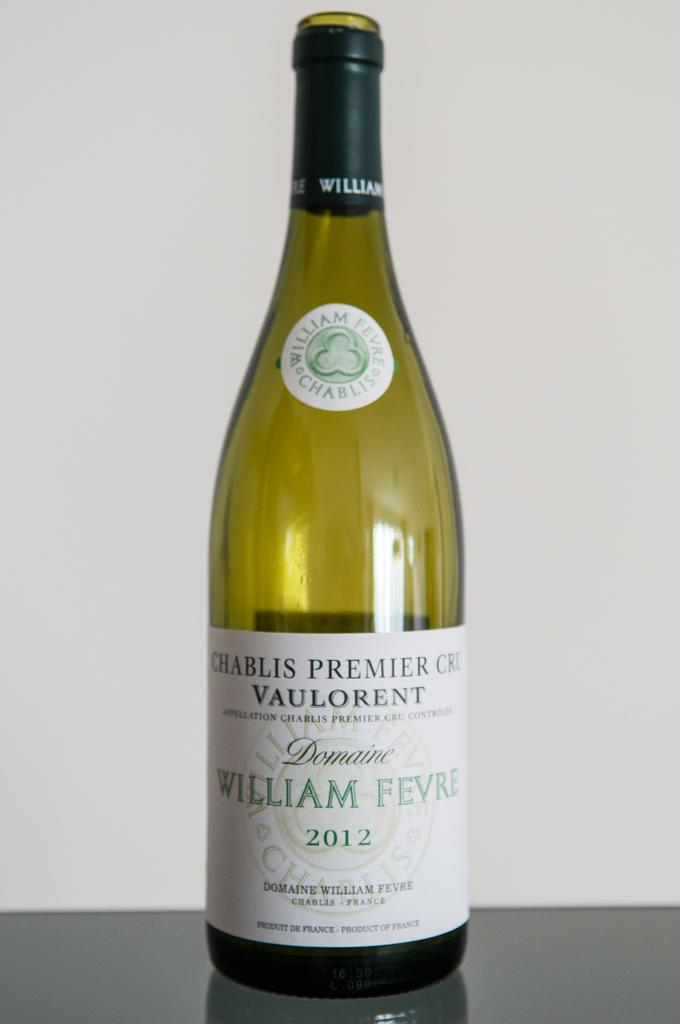<image>
Create a compact narrative representing the image presented. A bottle of "CHABLIS PREMIER CRU VAULORENT" is on a table. 